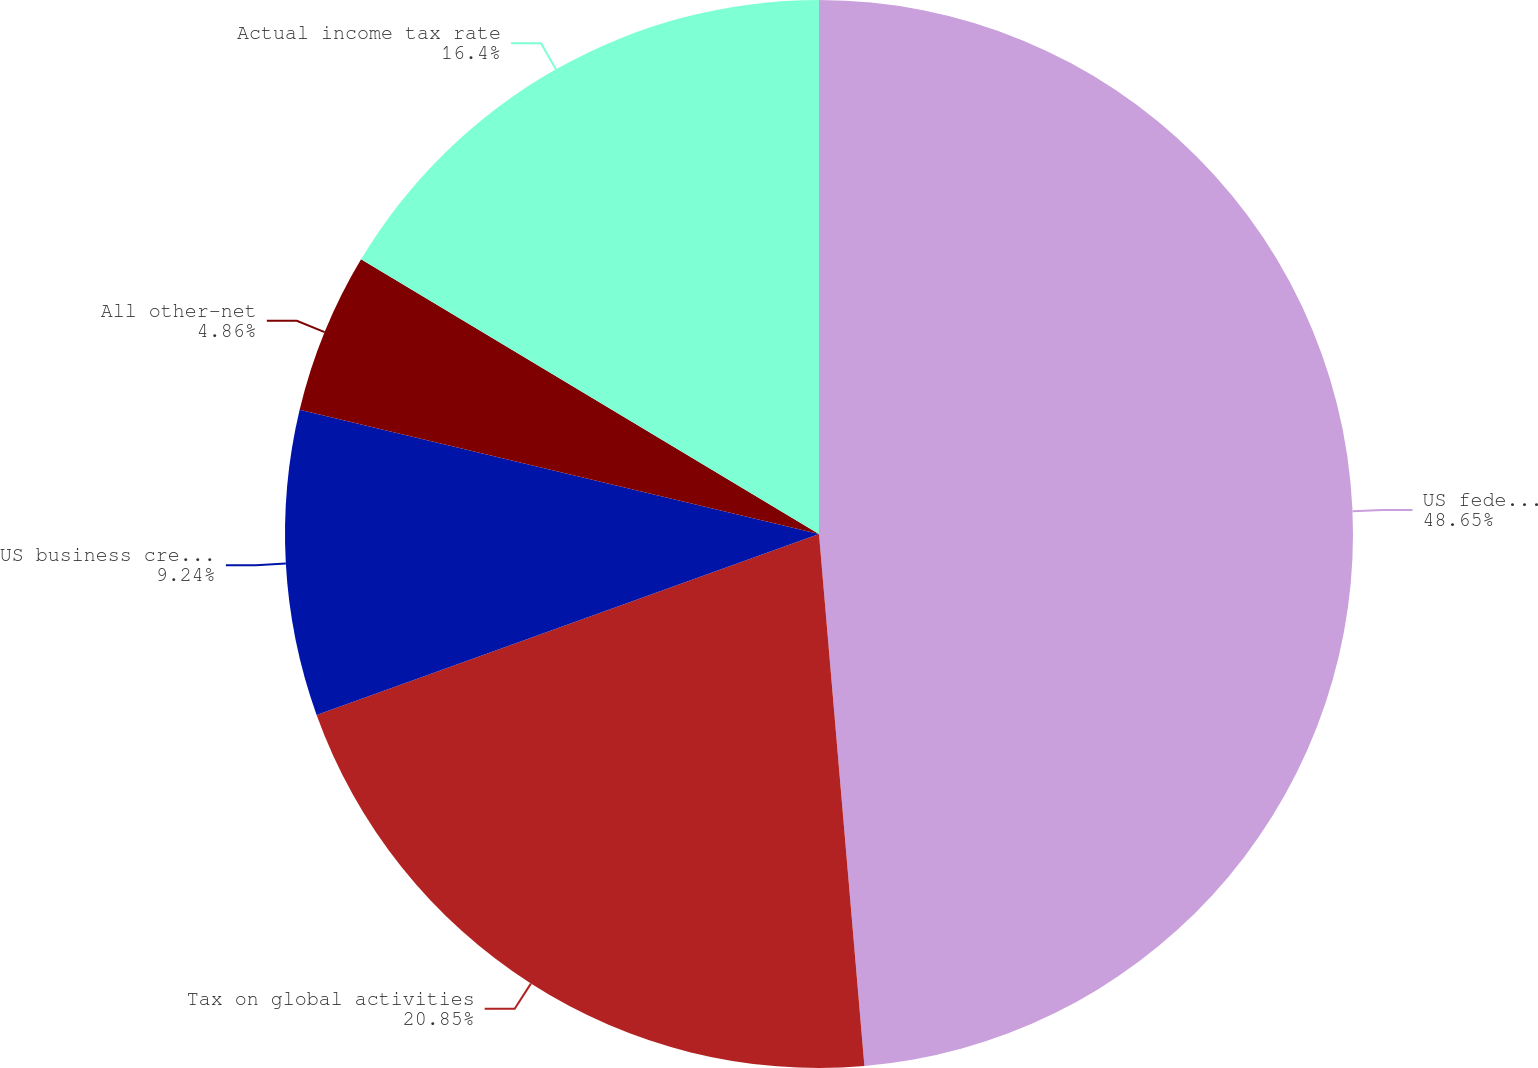Convert chart. <chart><loc_0><loc_0><loc_500><loc_500><pie_chart><fcel>US federal statutory income<fcel>Tax on global activities<fcel>US business credits (a)<fcel>All other-net<fcel>Actual income tax rate<nl><fcel>48.64%<fcel>20.85%<fcel>9.24%<fcel>4.86%<fcel>16.4%<nl></chart> 